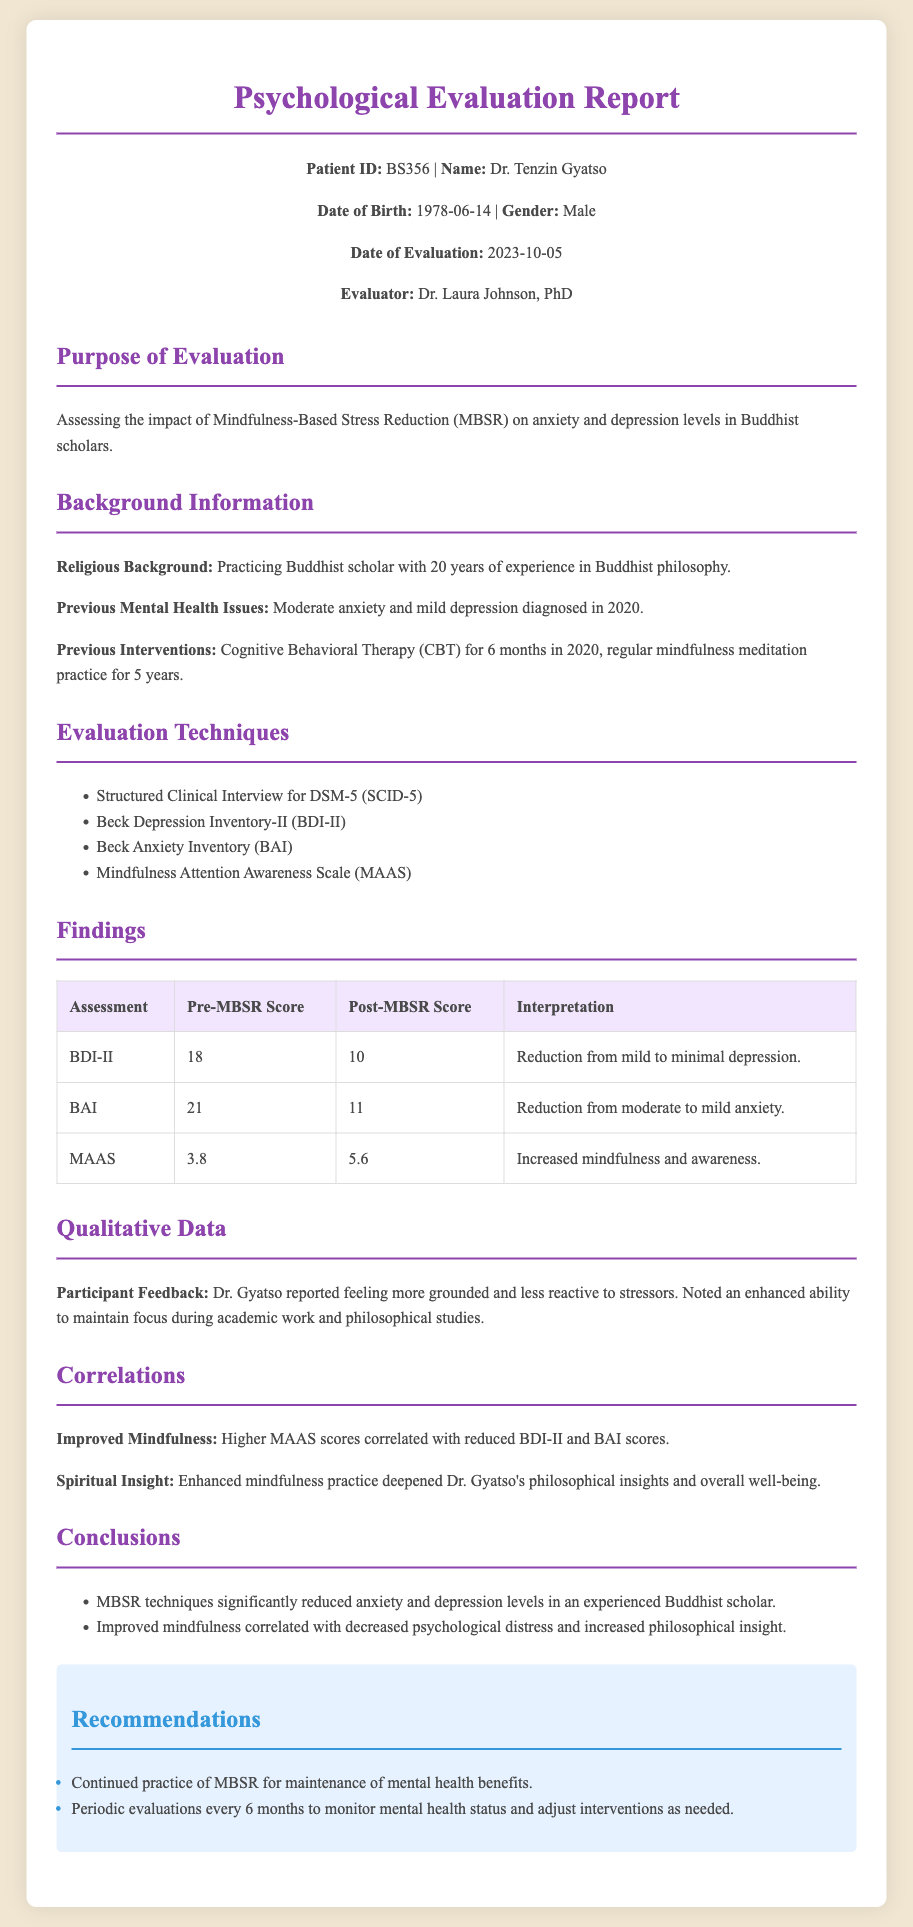What is the patient ID? The patient ID is a unique identifier for the individual being evaluated in the document.
Answer: BS356 Who is the evaluator? The evaluator is the individual responsible for conducting the psychological evaluation and providing the report.
Answer: Dr. Laura Johnson, PhD What was the pre-MBSR score for the BDI-II? The pre-MBSR score shows the level of depression before the application of MBSR techniques.
Answer: 18 What significant change occurred in the MAAS score? The change in MAAS score indicates the level of mindfulness and awareness before and after the MBSR intervention.
Answer: Increased mindfulness and awareness What correlation was found between MAAS scores and mental health? This correlation discusses the relationship between mindfulness levels and psychological conditions.
Answer: Higher MAAS scores correlated with reduced BDI-II and BAI scores What previous interventions did Dr. Tenzin Gyatso undergo? Previous interventions provide insight into the treatments the patient has received prior to this evaluation.
Answer: Cognitive Behavioral Therapy (CBT) for 6 months in 2020, regular mindfulness meditation practice for 5 years What are the recommendations following the evaluation? Recommendations are suggested actions or follow-ups based on the evaluation results.
Answer: Continued practice of MBSR for maintenance of mental health benefits What was the date of evaluation? The date specifies when the psychological evaluation took place, providing context for the findings.
Answer: 2023-10-05 